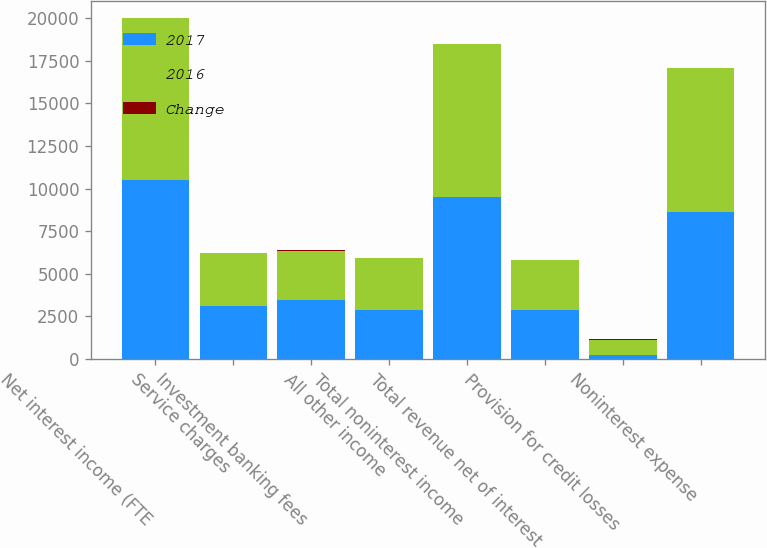Convert chart. <chart><loc_0><loc_0><loc_500><loc_500><stacked_bar_chart><ecel><fcel>Net interest income (FTE<fcel>Service charges<fcel>Investment banking fees<fcel>All other income<fcel>Total noninterest income<fcel>Total revenue net of interest<fcel>Provision for credit losses<fcel>Noninterest expense<nl><fcel>2017<fcel>10504<fcel>3125<fcel>3471<fcel>2899<fcel>9495<fcel>2891.5<fcel>212<fcel>8596<nl><fcel>2016<fcel>9471<fcel>3094<fcel>2884<fcel>2996<fcel>8974<fcel>2891.5<fcel>883<fcel>8486<nl><fcel>Change<fcel>11<fcel>1<fcel>20<fcel>3<fcel>6<fcel>8<fcel>76<fcel>1<nl></chart> 